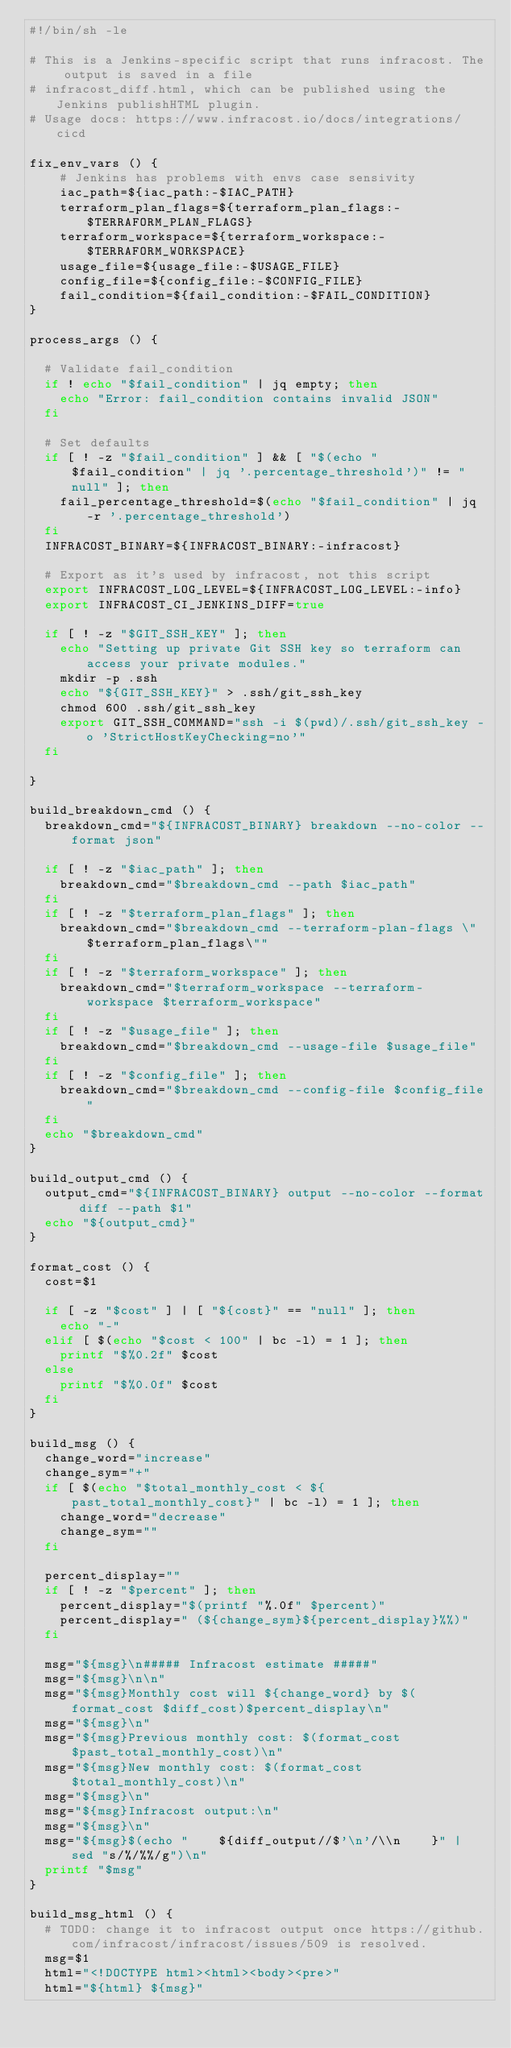<code> <loc_0><loc_0><loc_500><loc_500><_Bash_>#!/bin/sh -le

# This is a Jenkins-specific script that runs infracost. The output is saved in a file 
# infracost_diff.html, which can be published using the Jenkins publishHTML plugin.
# Usage docs: https://www.infracost.io/docs/integrations/cicd

fix_env_vars () {
    # Jenkins has problems with envs case sensivity
    iac_path=${iac_path:-$IAC_PATH}
    terraform_plan_flags=${terraform_plan_flags:-$TERRAFORM_PLAN_FLAGS}
    terraform_workspace=${terraform_workspace:-$TERRAFORM_WORKSPACE}
    usage_file=${usage_file:-$USAGE_FILE}
    config_file=${config_file:-$CONFIG_FILE}
    fail_condition=${fail_condition:-$FAIL_CONDITION}
}

process_args () {

  # Validate fail_condition
  if ! echo "$fail_condition" | jq empty; then
    echo "Error: fail_condition contains invalid JSON"
  fi

  # Set defaults
  if [ ! -z "$fail_condition" ] && [ "$(echo "$fail_condition" | jq '.percentage_threshold')" != "null" ]; then
    fail_percentage_threshold=$(echo "$fail_condition" | jq -r '.percentage_threshold')
  fi
  INFRACOST_BINARY=${INFRACOST_BINARY:-infracost}

  # Export as it's used by infracost, not this script
  export INFRACOST_LOG_LEVEL=${INFRACOST_LOG_LEVEL:-info}
  export INFRACOST_CI_JENKINS_DIFF=true

  if [ ! -z "$GIT_SSH_KEY" ]; then
    echo "Setting up private Git SSH key so terraform can access your private modules."
    mkdir -p .ssh
    echo "${GIT_SSH_KEY}" > .ssh/git_ssh_key
    chmod 600 .ssh/git_ssh_key
    export GIT_SSH_COMMAND="ssh -i $(pwd)/.ssh/git_ssh_key -o 'StrictHostKeyChecking=no'"
  fi

}

build_breakdown_cmd () {
  breakdown_cmd="${INFRACOST_BINARY} breakdown --no-color --format json"

  if [ ! -z "$iac_path" ]; then
    breakdown_cmd="$breakdown_cmd --path $iac_path"
  fi
  if [ ! -z "$terraform_plan_flags" ]; then
    breakdown_cmd="$breakdown_cmd --terraform-plan-flags \"$terraform_plan_flags\""
  fi
  if [ ! -z "$terraform_workspace" ]; then
    breakdown_cmd="$terraform_workspace --terraform-workspace $terraform_workspace"
  fi
  if [ ! -z "$usage_file" ]; then
    breakdown_cmd="$breakdown_cmd --usage-file $usage_file"
  fi
  if [ ! -z "$config_file" ]; then
    breakdown_cmd="$breakdown_cmd --config-file $config_file"
  fi
  echo "$breakdown_cmd"
}

build_output_cmd () {
  output_cmd="${INFRACOST_BINARY} output --no-color --format diff --path $1"
  echo "${output_cmd}"
}

format_cost () {
  cost=$1
    
  if [ -z "$cost" ] | [ "${cost}" == "null" ]; then
    echo "-"
  elif [ $(echo "$cost < 100" | bc -l) = 1 ]; then
    printf "$%0.2f" $cost
  else
    printf "$%0.0f" $cost
  fi
}

build_msg () {
  change_word="increase"
  change_sym="+"
  if [ $(echo "$total_monthly_cost < ${past_total_monthly_cost}" | bc -l) = 1 ]; then
    change_word="decrease"
    change_sym=""
  fi

  percent_display=""
  if [ ! -z "$percent" ]; then
    percent_display="$(printf "%.0f" $percent)"
    percent_display=" (${change_sym}${percent_display}%%)"
  fi

  msg="${msg}\n##### Infracost estimate #####"
  msg="${msg}\n\n"
  msg="${msg}Monthly cost will ${change_word} by $(format_cost $diff_cost)$percent_display\n"
  msg="${msg}\n"
  msg="${msg}Previous monthly cost: $(format_cost $past_total_monthly_cost)\n"
  msg="${msg}New monthly cost: $(format_cost $total_monthly_cost)\n"
  msg="${msg}\n"
  msg="${msg}Infracost output:\n"
  msg="${msg}\n"
  msg="${msg}$(echo "    ${diff_output//$'\n'/\\n    }" | sed "s/%/%%/g")\n"
  printf "$msg"
}

build_msg_html () {
  # TODO: change it to infracost output once https://github.com/infracost/infracost/issues/509 is resolved.
  msg=$1
  html="<!DOCTYPE html><html><body><pre>"
  html="${html} ${msg}"</code> 